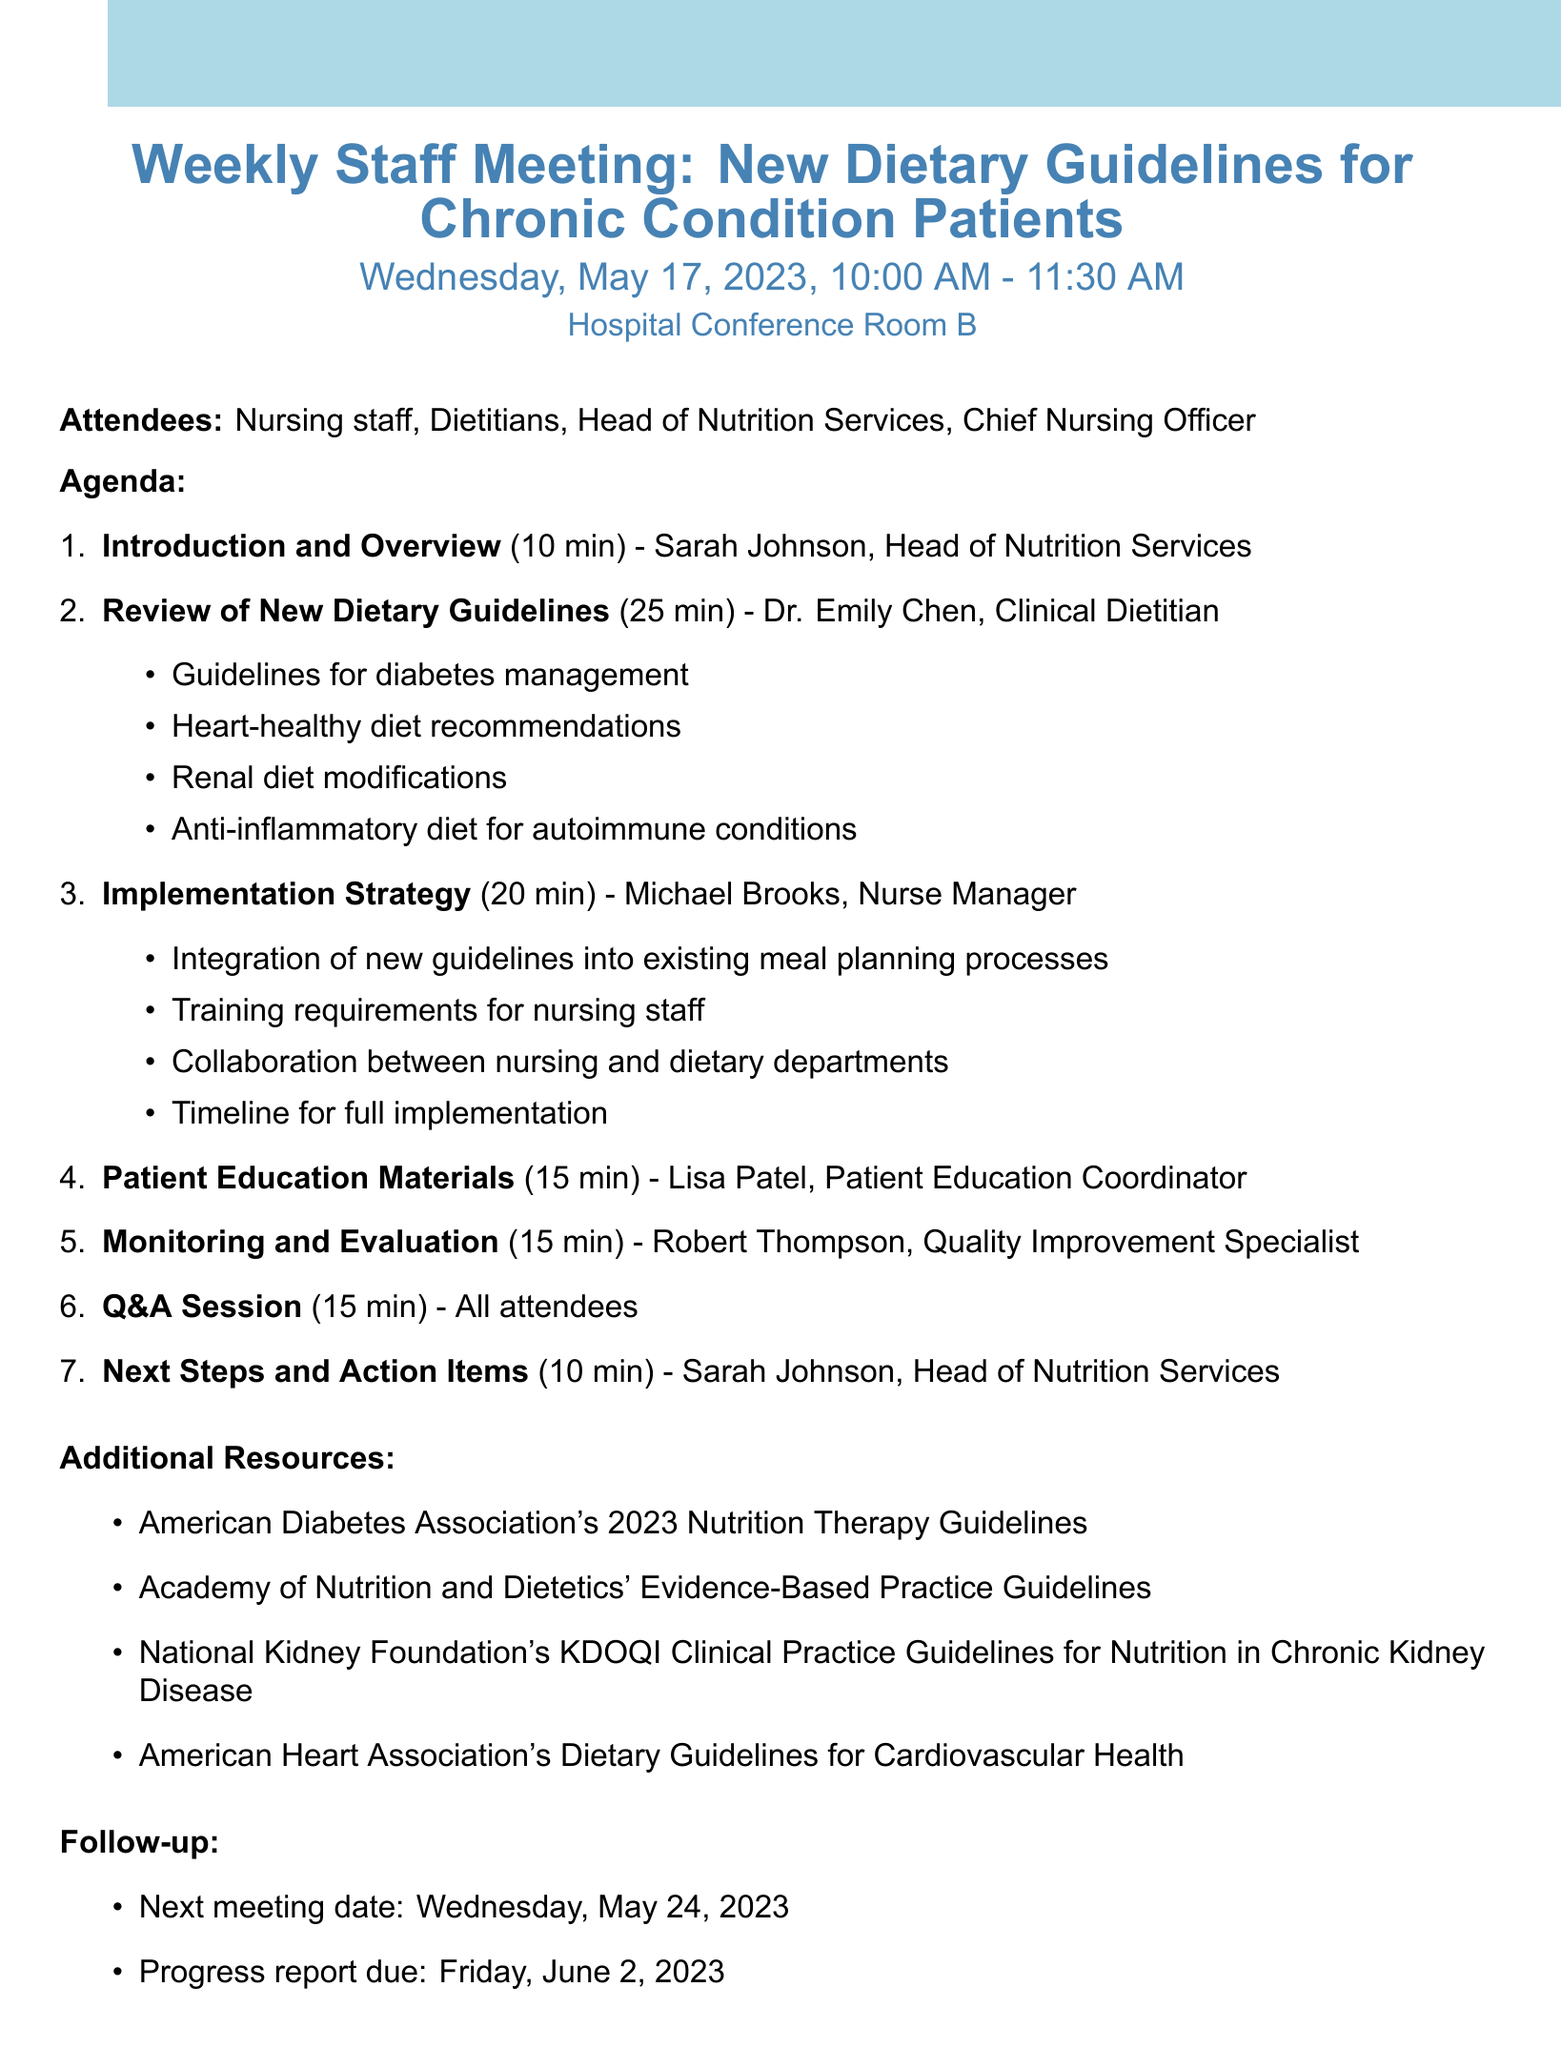what is the date of the meeting? The date of the meeting is provided in the document.
Answer: Wednesday, May 17, 2023 who is the presenter for the "Review of New Dietary Guidelines" item? The document lists the presenters for each agenda item.
Answer: Dr. Emily Chen how long is the "Patient Education Materials" agenda item scheduled for? The duration for each agenda item is specified in the document.
Answer: 15 minutes what are the guidelines reviewed related to diabetes management? The details of the guidelines are listed under the "Review of New Dietary Guidelines".
Answer: Guidelines for diabetes management who is responsible for the "Next Steps and Action Items" section? The document indicates the presenters for each agenda item.
Answer: Sarah Johnson, Head of Nutrition Services what materials are referenced as additional resources? The document includes a list of additional resources at the end.
Answer: American Diabetes Association's 2023 Nutrition Therapy Guidelines what is the next meeting date? The document specifies the next meeting date in the follow-up section.
Answer: Wednesday, May 24, 2023 how many attendees are listed in the document? The number of attendees can be counted in the list provided.
Answer: 4 